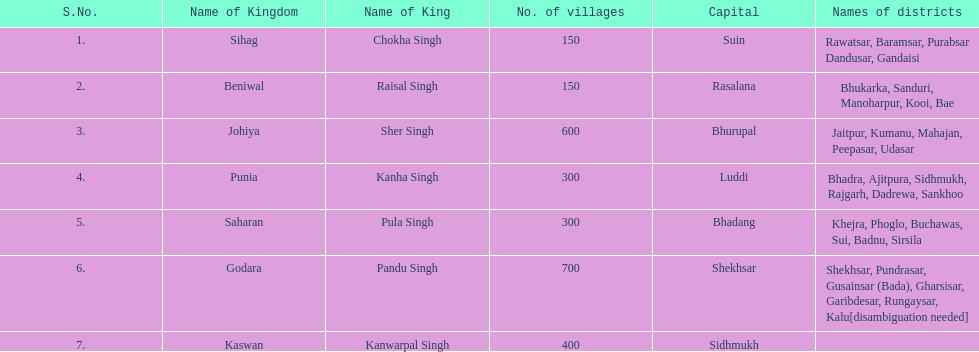He was the sovereign of the sihag kingdom. Chokha Singh. 